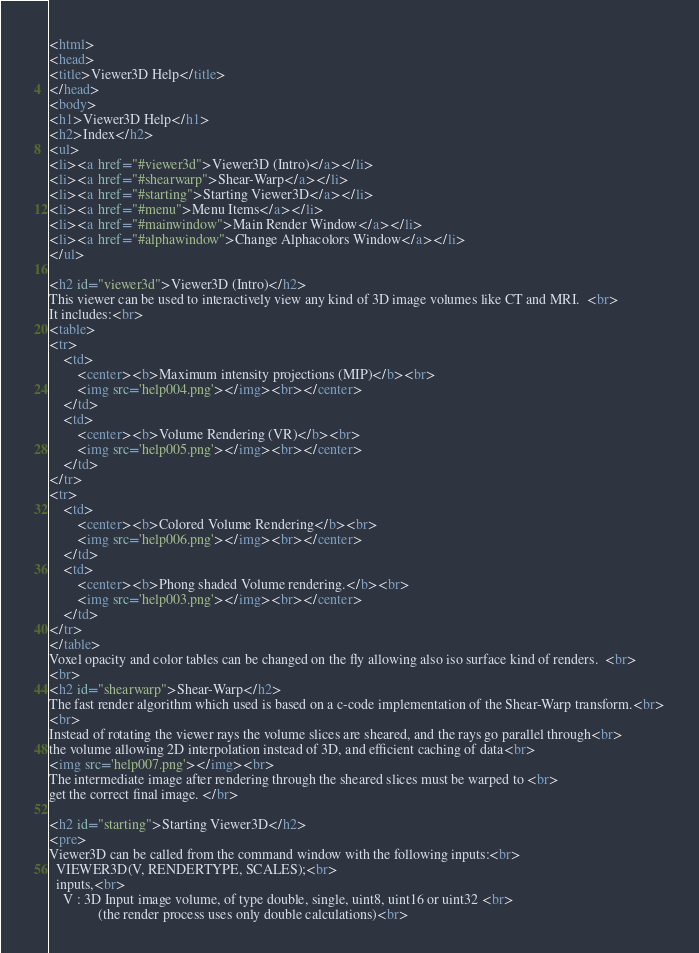<code> <loc_0><loc_0><loc_500><loc_500><_HTML_><html>
<head>
<title>Viewer3D Help</title>
</head>
<body>
<h1>Viewer3D Help</h1>
<h2>Index</h2>
<ul>
<li><a href="#viewer3d">Viewer3D (Intro)</a></li>
<li><a href="#shearwarp">Shear-Warp</a></li>
<li><a href="#starting">Starting Viewer3D</a></li>
<li><a href="#menu">Menu Items</a></li>
<li><a href="#mainwindow">Main Render Window</a></li>
<li><a href="#alphawindow">Change Alphacolors Window</a></li>
</ul>

<h2 id="viewer3d">Viewer3D (Intro)</h2>
This viewer can be used to interactively view any kind of 3D image volumes like CT and MRI.  <br>
It includes:<br>
<table>
<tr>
	<td>
		<center><b>Maximum intensity projections (MIP)</b><br>
		<img src='help004.png'></img><br></center>
	</td>
	<td>
		<center><b>Volume Rendering (VR)</b><br>
		<img src='help005.png'></img><br></center>
	</td>
</tr>
<tr>
	<td>
		<center><b>Colored Volume Rendering</b><br>
		<img src='help006.png'></img><br></center>
	</td>
	<td>
		<center><b>Phong shaded Volume rendering.</b><br> 
		<img src='help003.png'></img><br></center>
	</td>
</tr>
</table>
Voxel opacity and color tables can be changed on the fly allowing also iso surface kind of renders.  <br>
<br>
<h2 id="shearwarp">Shear-Warp</h2>
The fast render algorithm which used is based on a c-code implementation of the Shear-Warp transform.<br>
<br>
Instead of rotating the viewer rays the volume slices are sheared, and the rays go parallel through<br>
the volume allowing 2D interpolation instead of 3D, and efficient caching of data<br>  
<img src='help007.png'></img><br>
The intermediate image after rendering through the sheared slices must be warped to <br>
get the correct final image. </br>

<h2 id="starting">Starting Viewer3D</h2>
<pre>
Viewer3D can be called from the command window with the following inputs:<br>
  VIEWER3D(V, RENDERTYPE, SCALES);<br>
  inputs,<br>
    V : 3D Input image volume, of type double, single, uint8, uint16 or uint32 <br>
              (the render process uses only double calculations)<br></code> 